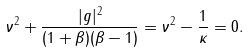Convert formula to latex. <formula><loc_0><loc_0><loc_500><loc_500>\nu ^ { 2 } + \frac { | g | ^ { 2 } } { ( 1 + \beta ) ( \beta - 1 ) } = \nu ^ { 2 } - \frac { 1 } { \kappa } = 0 .</formula> 